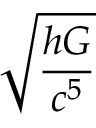<formula> <loc_0><loc_0><loc_500><loc_500>\sqrt { \frac { h G } { c ^ { 5 } } }</formula> 